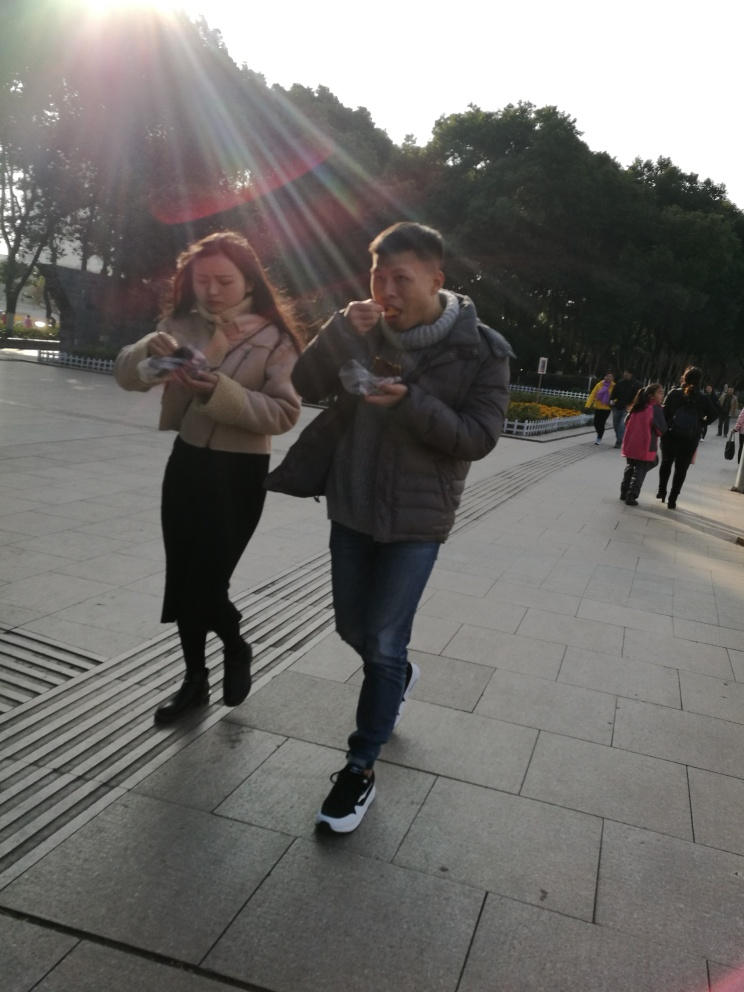Is there excessive noise in the photo? The photo portrays a clear scene without visible grain or artifacts that would indicate excessive noise. The clarity is especially notable despite the direct sunlight which can sometimes cause issues in photography. 